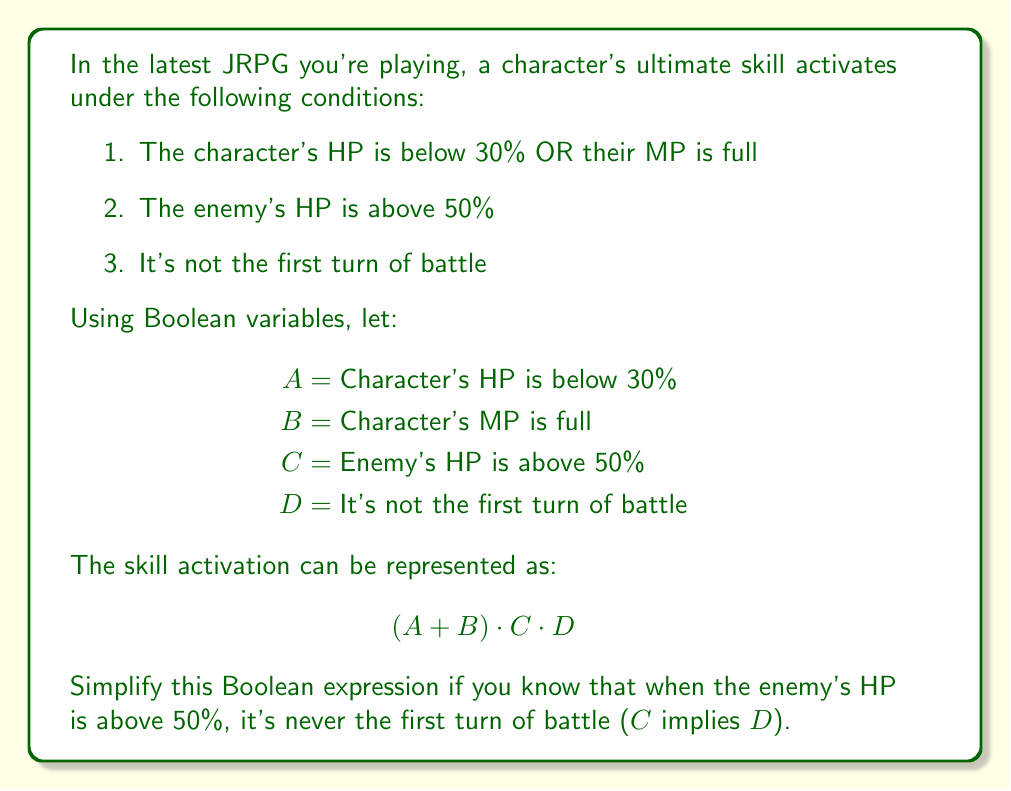Help me with this question. Let's approach this step-by-step:

1) We start with the expression: $$(A + B) \cdot C \cdot D$$

2) We're given that C implies D. In Boolean algebra, this can be written as $C \leq D$ or $C + D' = 1$, where $D'$ is the complement of D.

3) Using this information, we can simplify $C \cdot D$ to just $C$:
   $C \cdot D = C$ (because if C is true, D must be true)

4) Our expression now becomes:
   $$(A + B) \cdot C$$

5) We can't simplify this further without more information about the relationships between A, B, and C.

Therefore, the simplified expression is $(A + B) \cdot C$.

This means the skill activates when the enemy's HP is above 50% AND either the character's HP is below 30% OR their MP is full.
Answer: $(A + B) \cdot C$ 